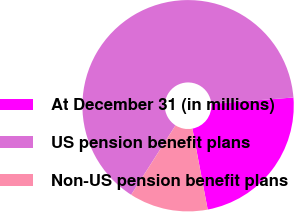Convert chart. <chart><loc_0><loc_0><loc_500><loc_500><pie_chart><fcel>At December 31 (in millions)<fcel>US pension benefit plans<fcel>Non-US pension benefit plans<nl><fcel>23.27%<fcel>64.71%<fcel>12.02%<nl></chart> 